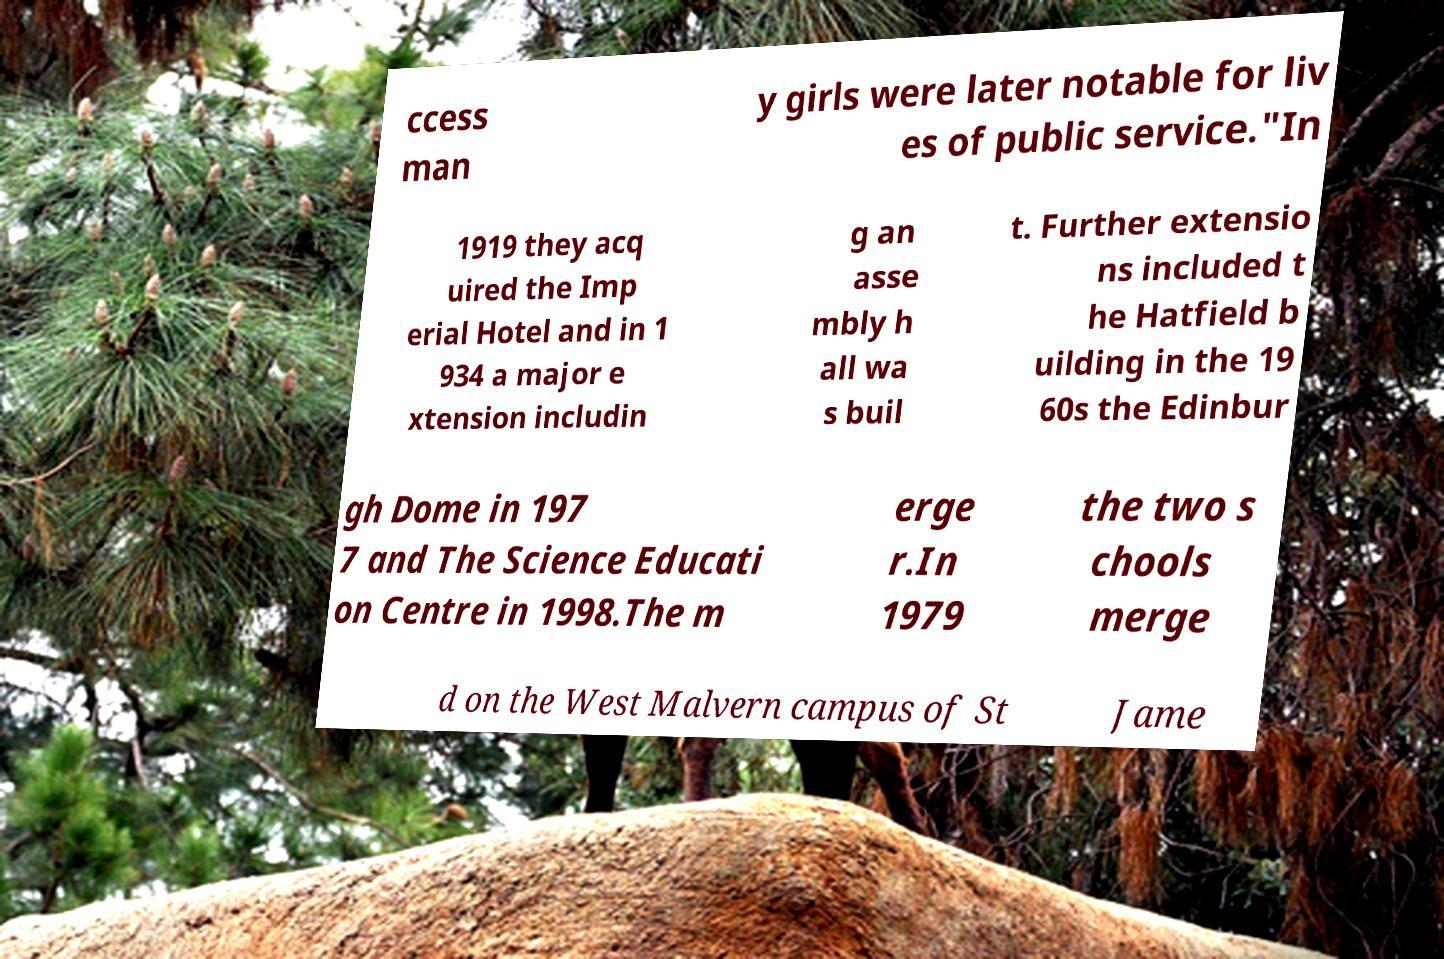Could you extract and type out the text from this image? ccess man y girls were later notable for liv es of public service."In 1919 they acq uired the Imp erial Hotel and in 1 934 a major e xtension includin g an asse mbly h all wa s buil t. Further extensio ns included t he Hatfield b uilding in the 19 60s the Edinbur gh Dome in 197 7 and The Science Educati on Centre in 1998.The m erge r.In 1979 the two s chools merge d on the West Malvern campus of St Jame 